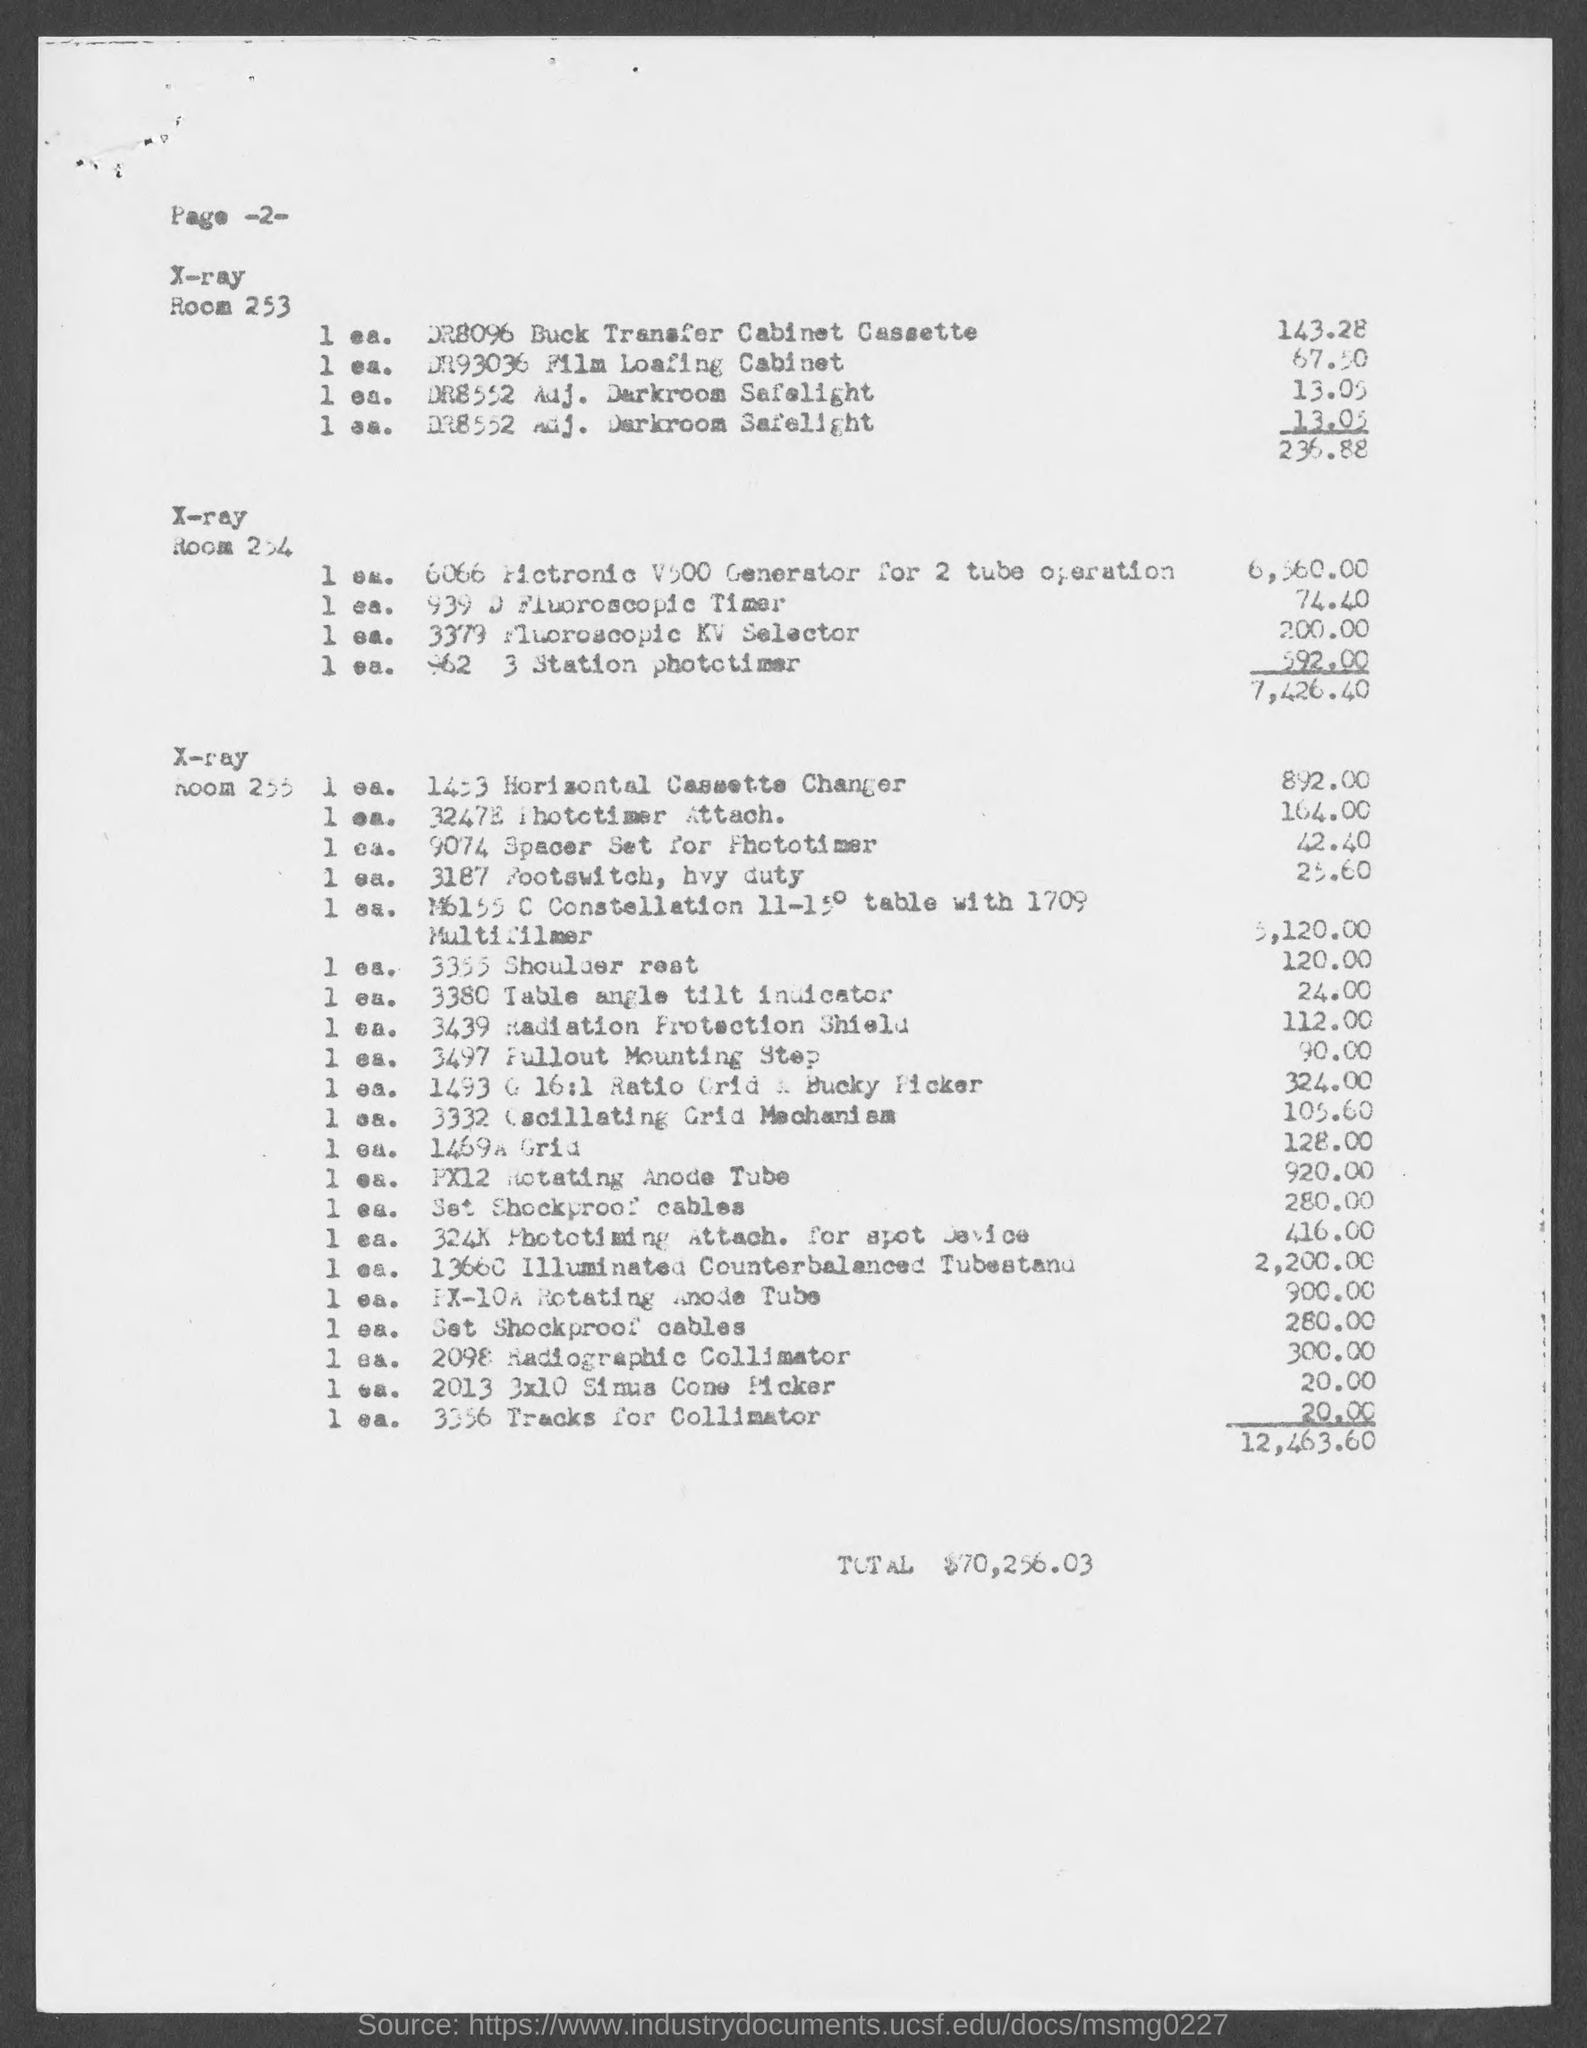Indicate a few pertinent items in this graphic. The total amount given in the document is $70,256.03. 